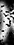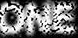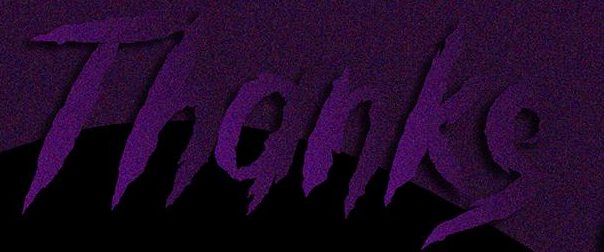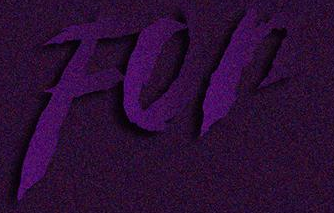Read the text content from these images in order, separated by a semicolon. ); ONE; Thanks; For 